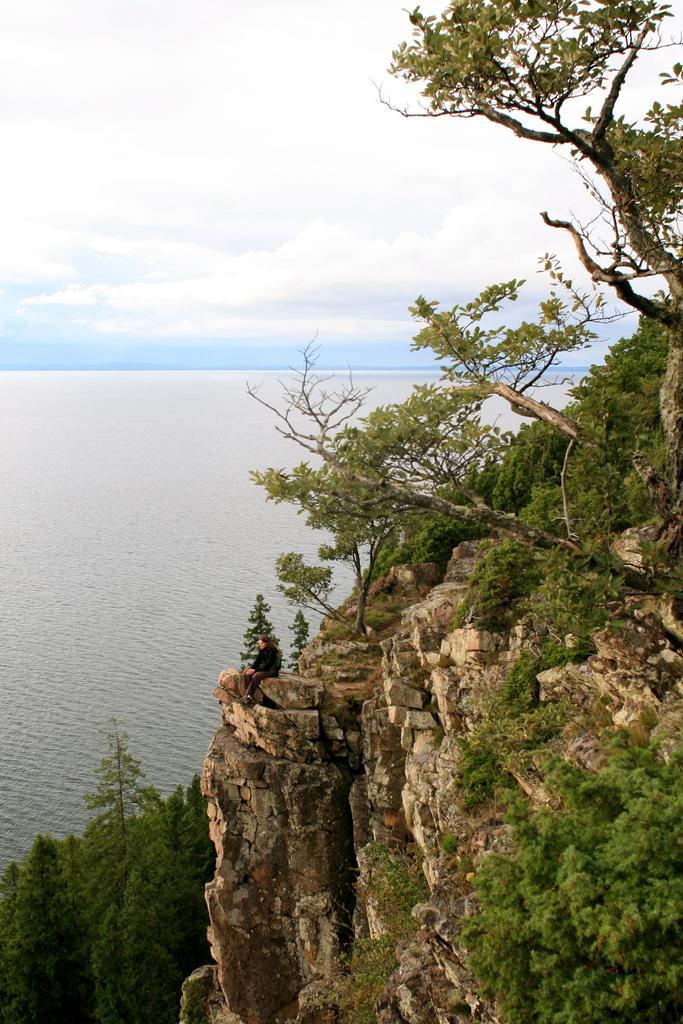What can be seen on the left side of the image? There is water on the left side of the image. What is located on the right side of the image? There are trees and rock mountains on the right side of the image. What is the person in the image doing? The person is sitting on the rock mountains. What is visible in the background of the image? The sky is visible in the background of the image. How many pizzas are being held by the person sitting on the rock mountains? There are no pizzas present in the image. What type of sign can be seen in the image? There is no sign present in the image. 